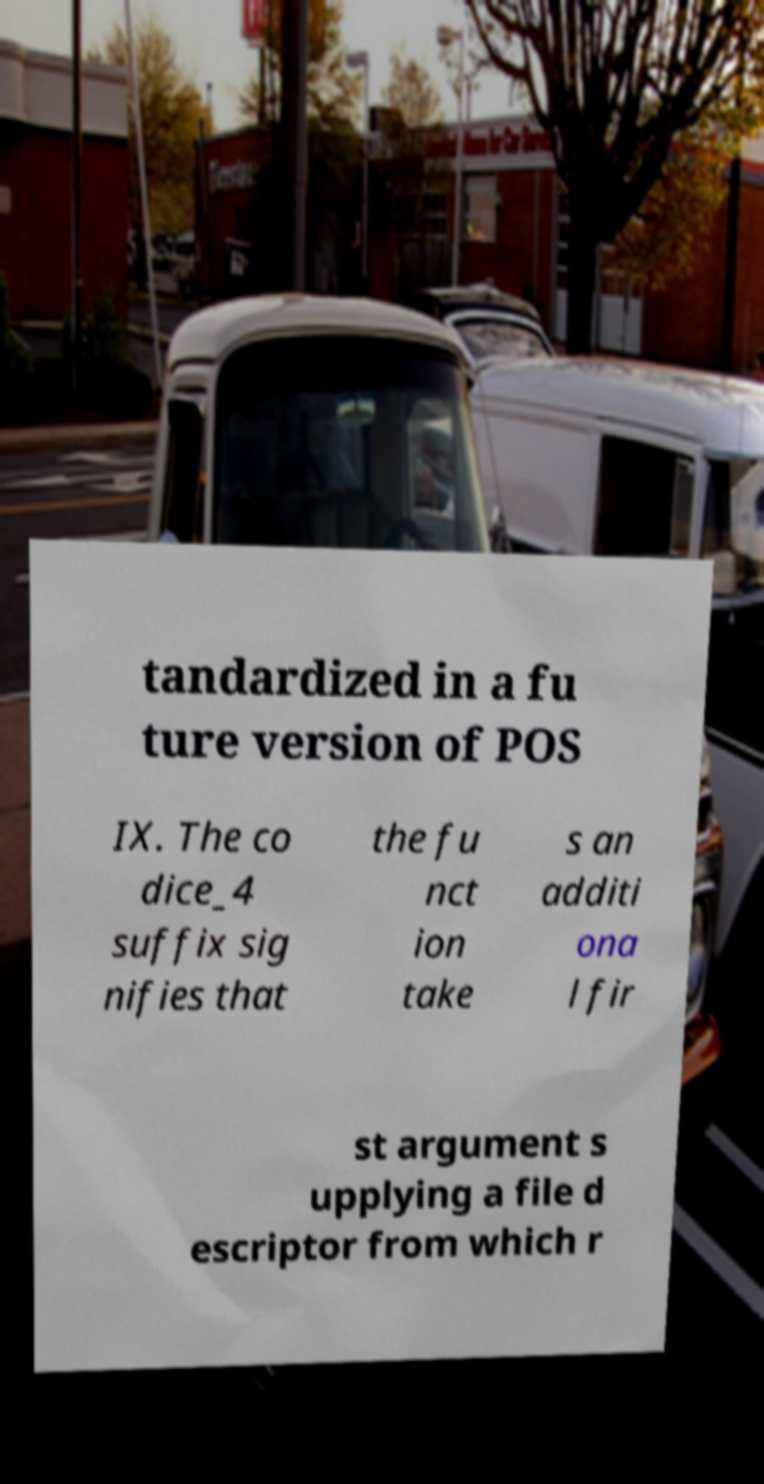What messages or text are displayed in this image? I need them in a readable, typed format. tandardized in a fu ture version of POS IX. The co dice_4 suffix sig nifies that the fu nct ion take s an additi ona l fir st argument s upplying a file d escriptor from which r 